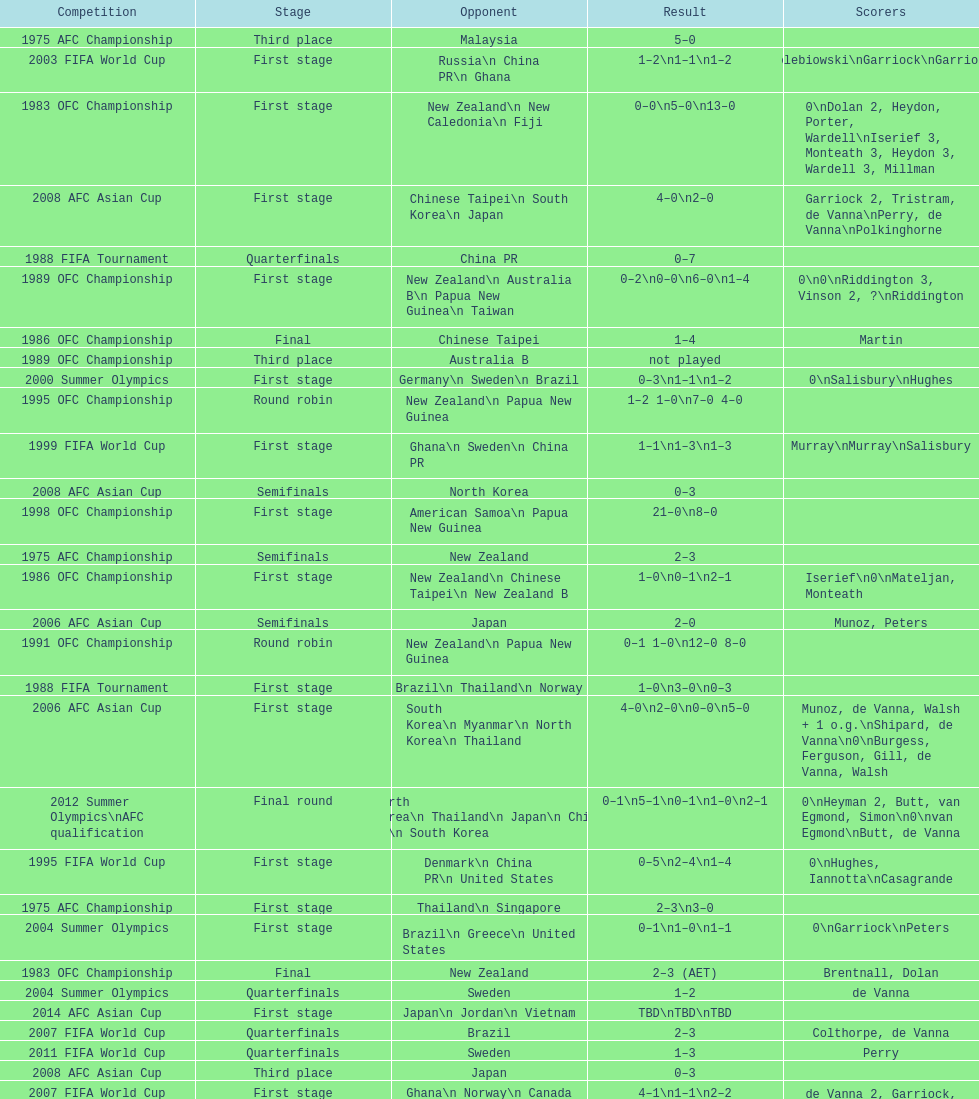How many stages were round robins? 3. 